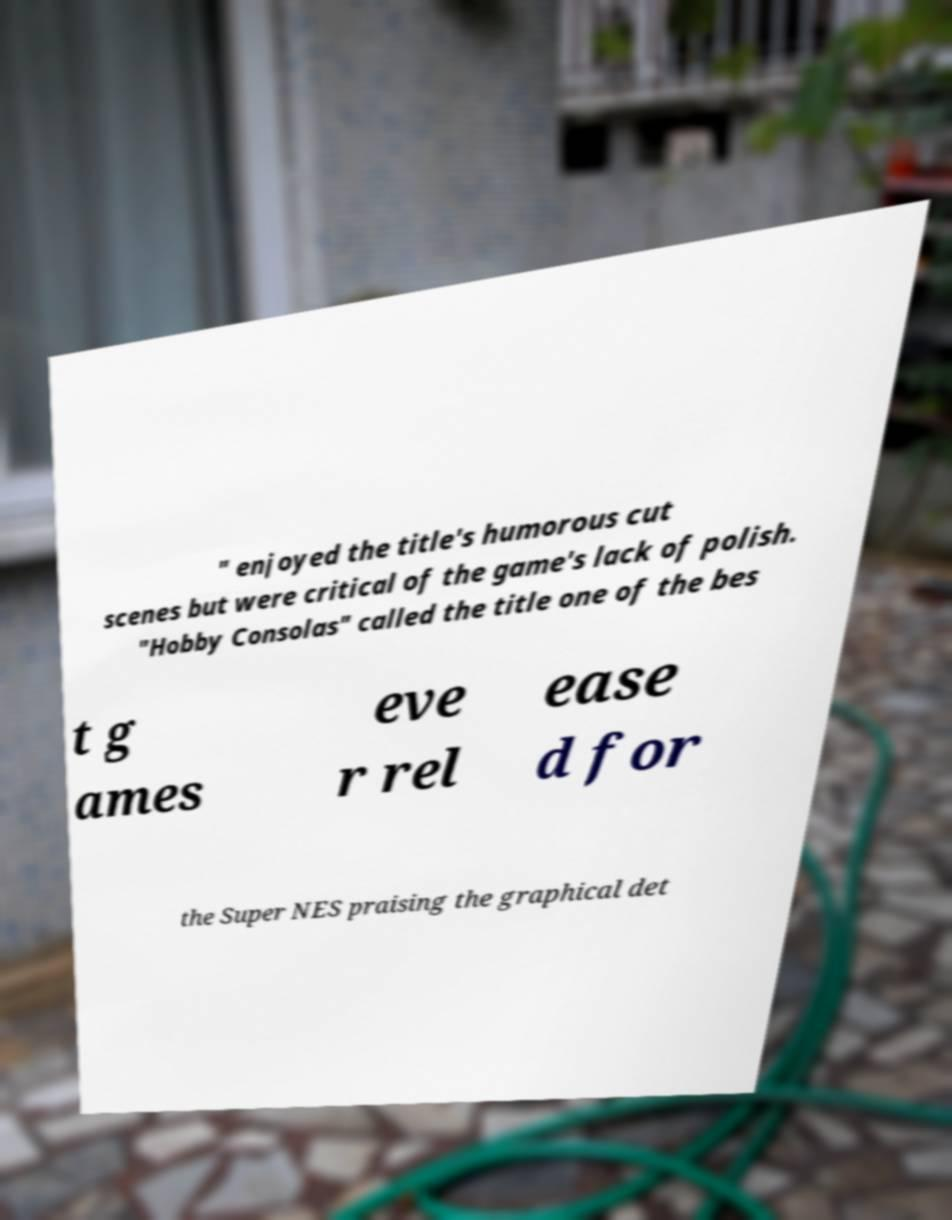Please read and relay the text visible in this image. What does it say? " enjoyed the title's humorous cut scenes but were critical of the game's lack of polish. "Hobby Consolas" called the title one of the bes t g ames eve r rel ease d for the Super NES praising the graphical det 